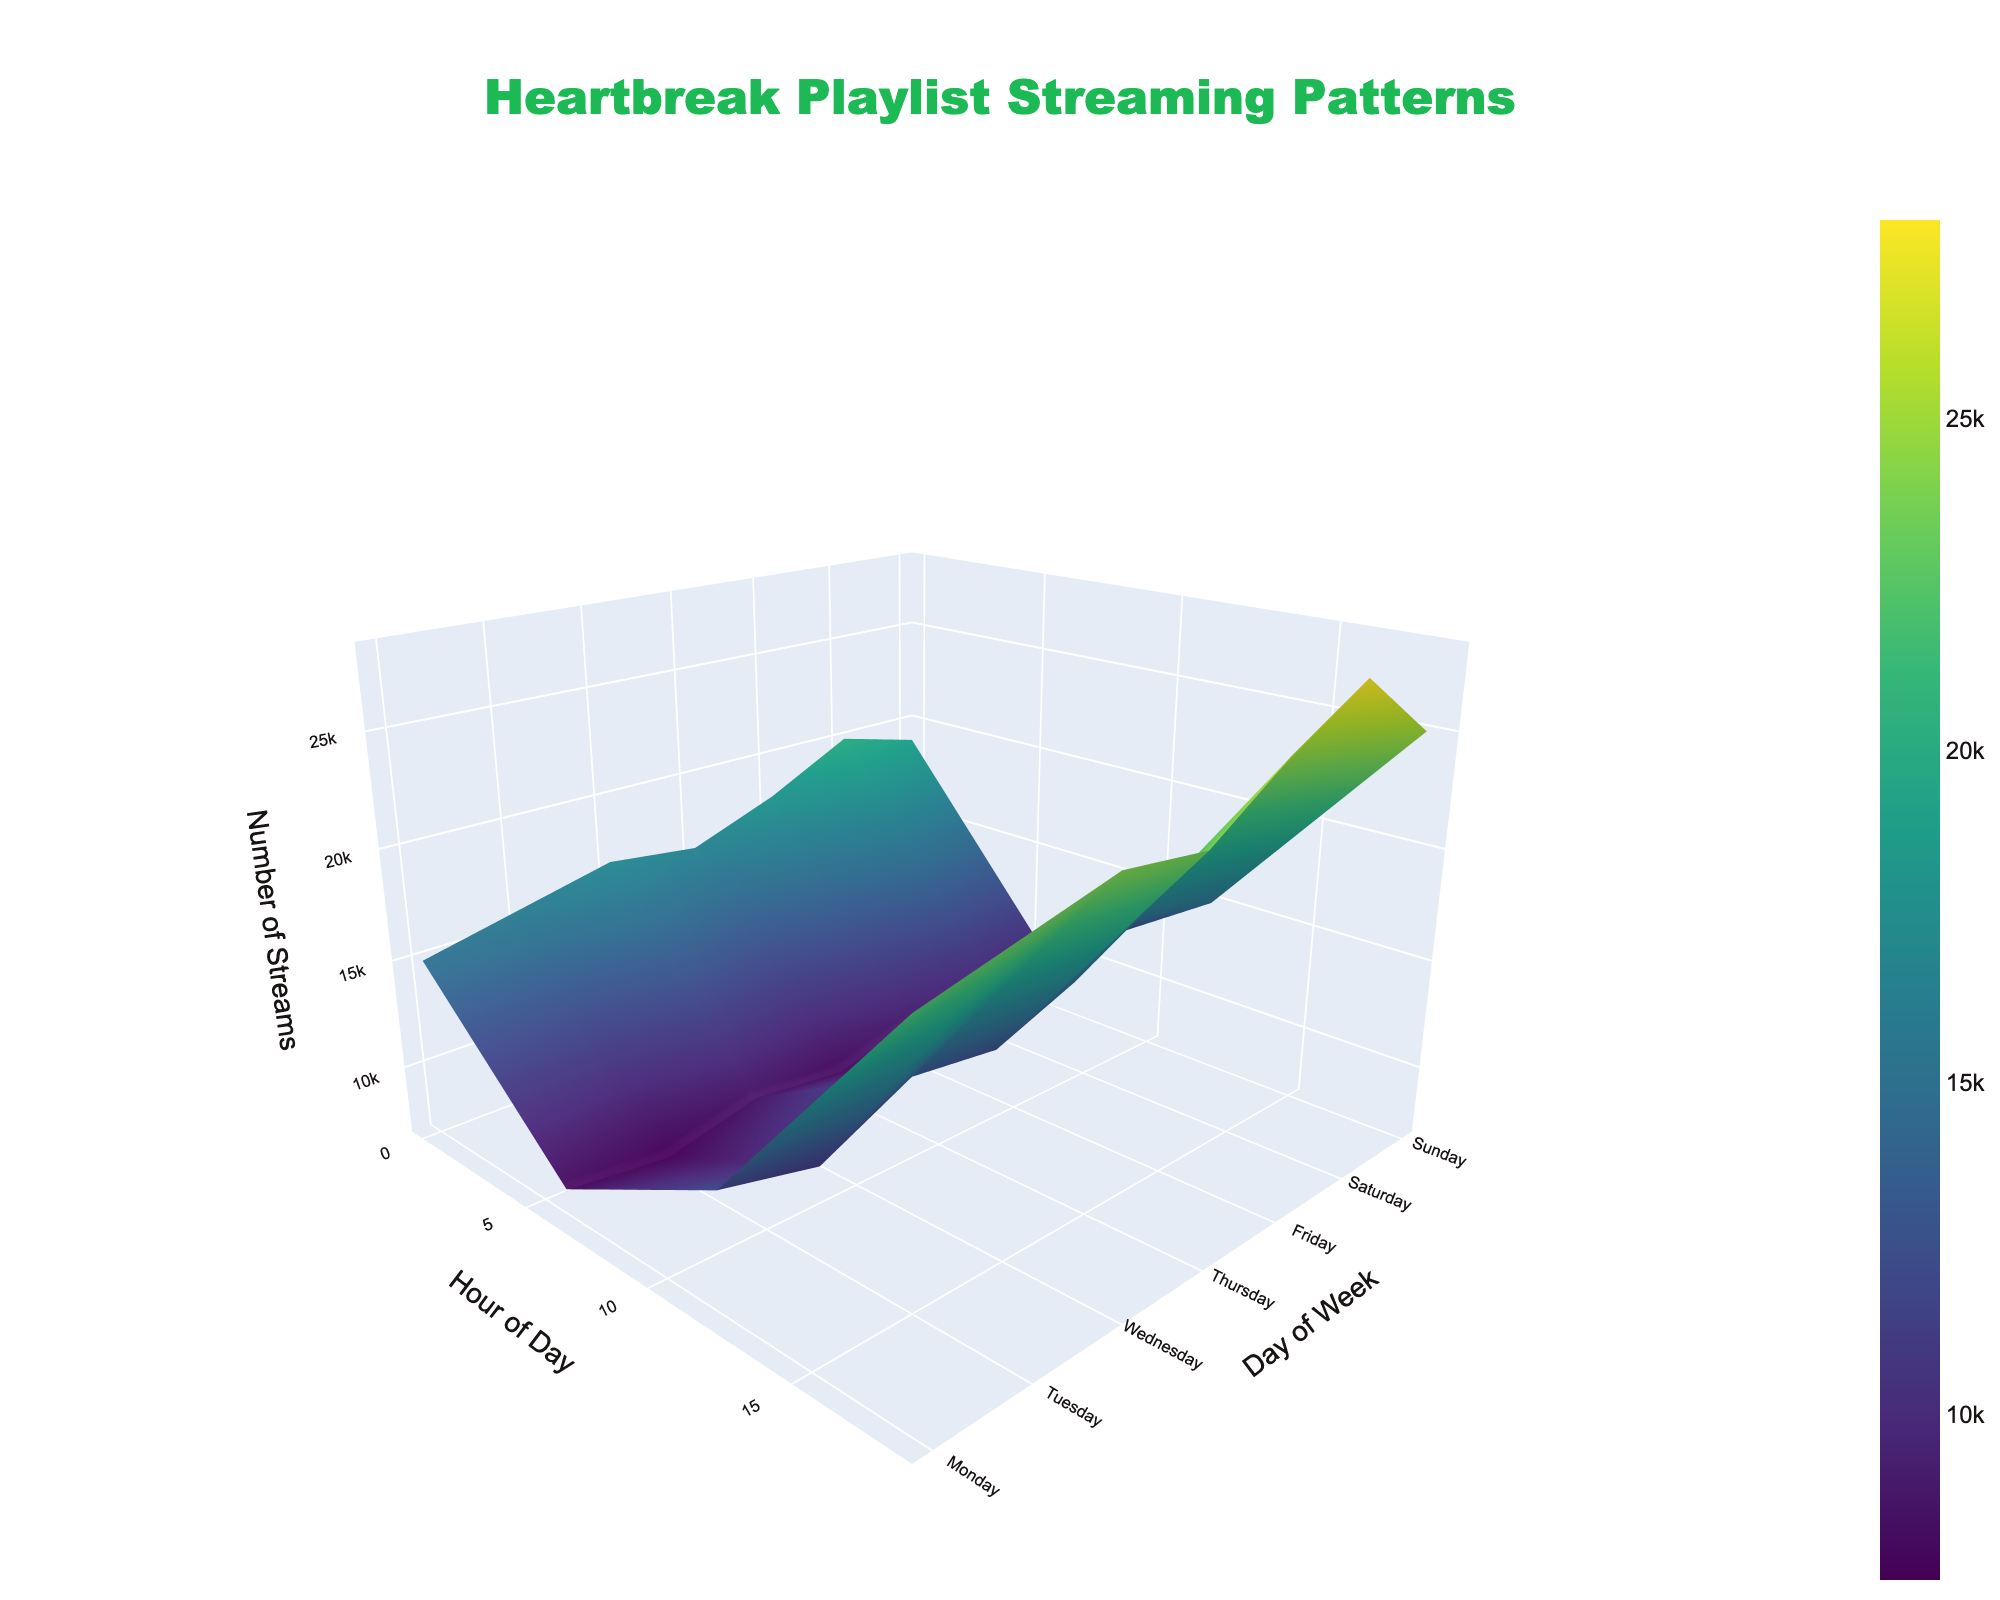What's the title of the plot? The title is written at the top center of the plot and is likely the most visually prominent text element.
Answer: Heartbreak Playlist Streaming Patterns Which day and hour have the highest number of streams? By examining the highest point on the surface, it appears to be on Saturday at 6 PM.
Answer: Saturday, 18:00 How do the streaming patterns change between Monday at midnight and Monday at 6 AM? Comparing the z-values (streams) at these two points, there's a noticeable decrease from 15,000 to 8,000.
Answer: Decreases What's the difference in streams between Tuesday at midnight and Tuesday at 6 AM? Subtract the streams for Tuesday 6 AM from Tuesday midnight, 16,000 - 7,500.
Answer: 8,500 Which day shows a consistent increase in streams from morning to evening? By inspecting the surface visually for hourly trends, Saturday shows a consistent increase from 10,000 at 6 AM to 28,000 at 6 PM.
Answer: Saturday Does Sunday at noon have more or fewer streams compared to Thursday at noon? Comparing the z-values at these times, Sunday at noon has 15,000 streams, and Thursday at noon has 12,500 streams.
Answer: More On which day do streams peak at midnight? Comparing the z-values at midnight across the days, Saturday shows the highest peak of 20,000 streams.
Answer: Saturday What’s the average number of streams on Wednesday? Summing up the streams on Wednesday (17,000 + 8,500 + 13,000 + 24,000) and dividing by 4. (62,500 / 4)
Answer: 15,625 How does the surface color change over the days in the plot? The color of the surface on this Viridis scale ranges from dark blue (low streams) to bright yellow (high streams), and it varies across the surface based on stream values.
Answer: Dark blue to bright yellow Which hour, on average, seems to have the highest streaming activity across all days? By comparing and estimating the z-values across all days for each hour, 6 PM consistently appears high.
Answer: 18:00 